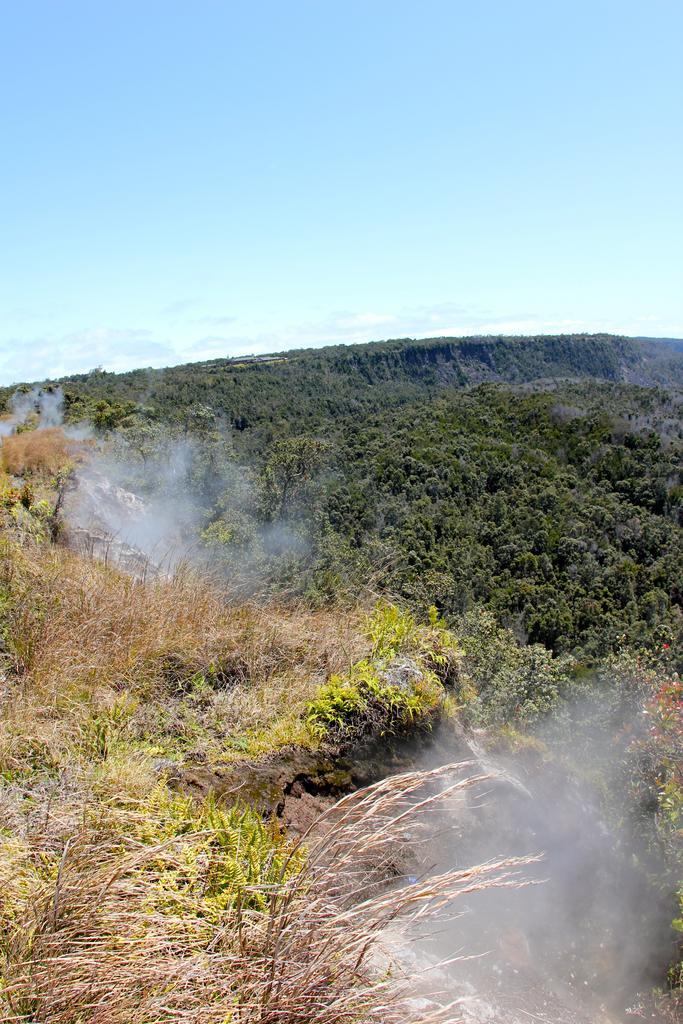In one or two sentences, can you explain what this image depicts? This picture is clicked outside. In the foreground we can see the grass and the plants and some smoke. In the background we can see the sky. 